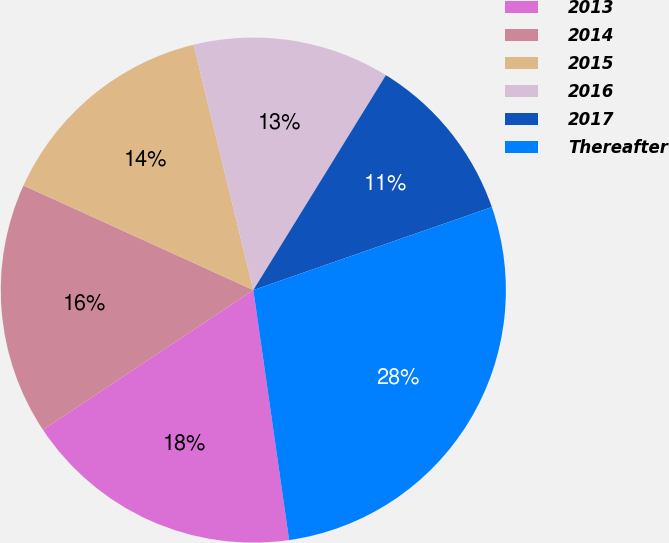Convert chart to OTSL. <chart><loc_0><loc_0><loc_500><loc_500><pie_chart><fcel>2013<fcel>2014<fcel>2015<fcel>2016<fcel>2017<fcel>Thereafter<nl><fcel>17.93%<fcel>16.13%<fcel>14.4%<fcel>12.6%<fcel>10.87%<fcel>28.07%<nl></chart> 